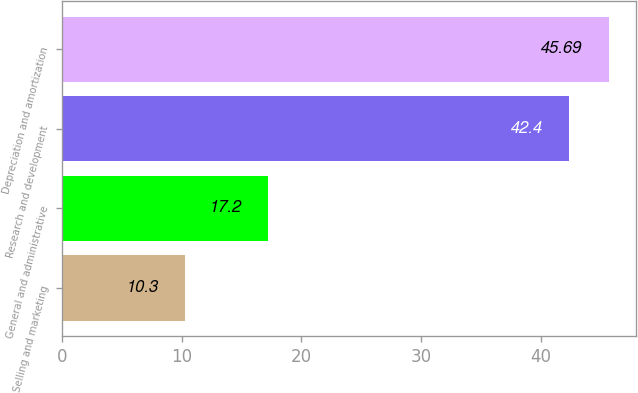Convert chart. <chart><loc_0><loc_0><loc_500><loc_500><bar_chart><fcel>Selling and marketing<fcel>General and administrative<fcel>Research and development<fcel>Depreciation and amortization<nl><fcel>10.3<fcel>17.2<fcel>42.4<fcel>45.69<nl></chart> 